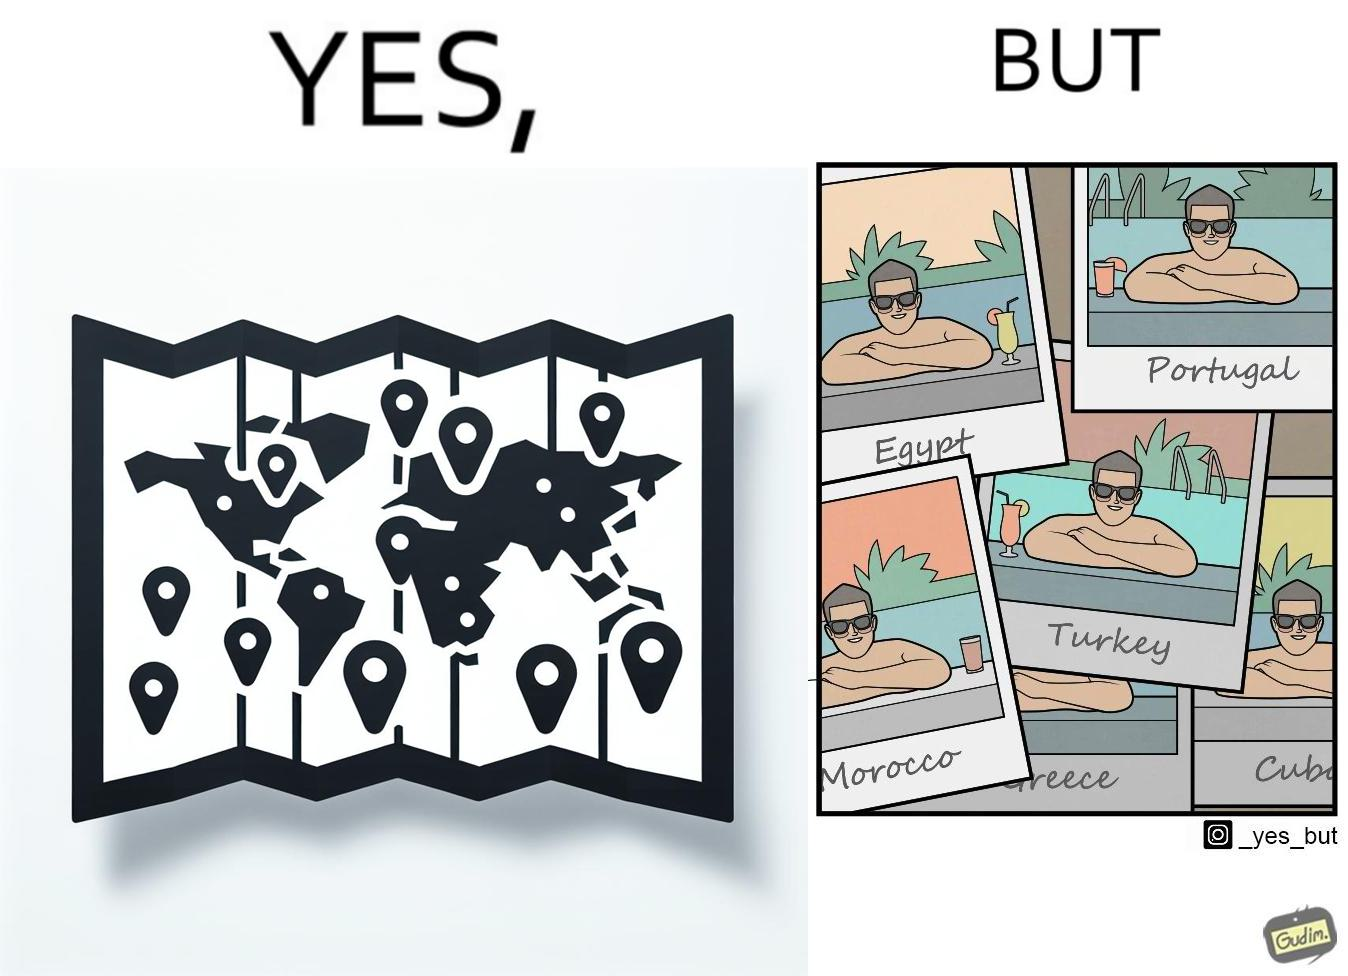What is shown in this image? The image is satirical because while the man has visited all the place marked on the map, he only seems to have swam in pools in all these differnt countries and has not actually seen these places. 